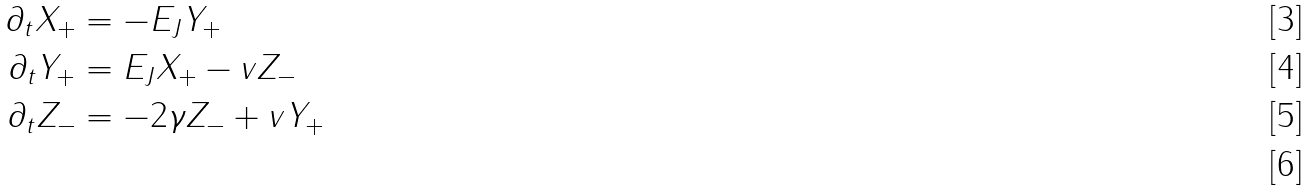<formula> <loc_0><loc_0><loc_500><loc_500>\partial _ { t } X _ { + } & = - E _ { J } Y _ { + } \\ \partial _ { t } Y _ { + } & = E _ { J } X _ { + } - v Z _ { - } \\ \partial _ { t } Z _ { - } & = - 2 \gamma Z _ { - } + v Y _ { + } \\</formula> 